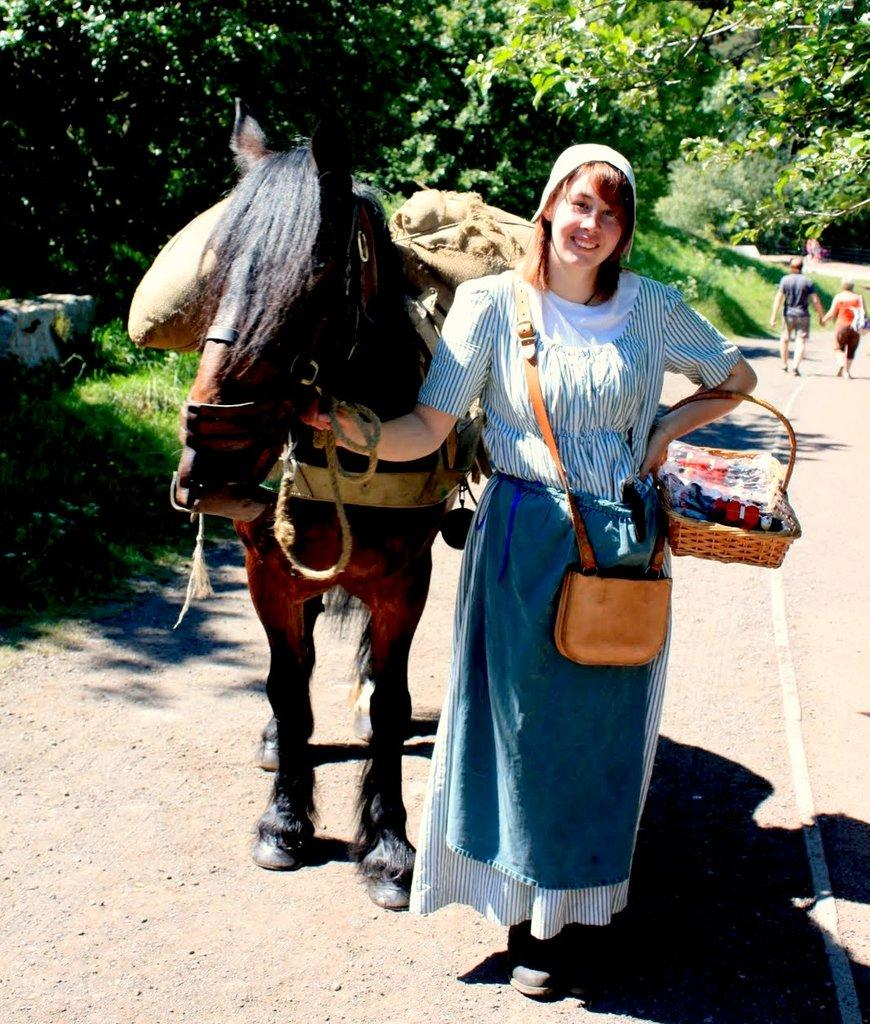What is the woman in the image holding? The woman is holding a basket and a rope. What is the woman standing beside in the image? The woman is standing beside a horse. What type of vegetation is visible in the image? There is grass visible in the image. What can be seen in the background of the image? There is a group of trees in the image. Are there any other people in the image besides the woman? Yes, there are people standing on a pathway in the image. Can you see any icicles hanging from the trees in the image? There are no icicles visible in the image; it appears to be a warm and grassy environment. What type of sand can be seen on the beach in the image? There is no beach or sand present in the image; it features a woman, a horse, and a group of trees. 